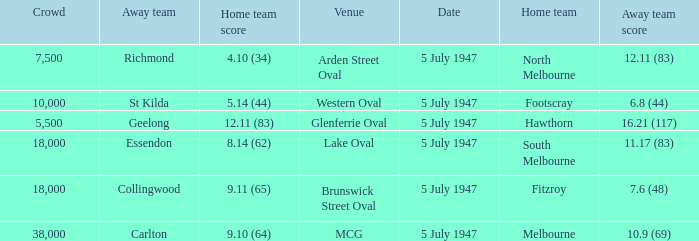What home team played an away team with a score of 6.8 (44)? Footscray. 